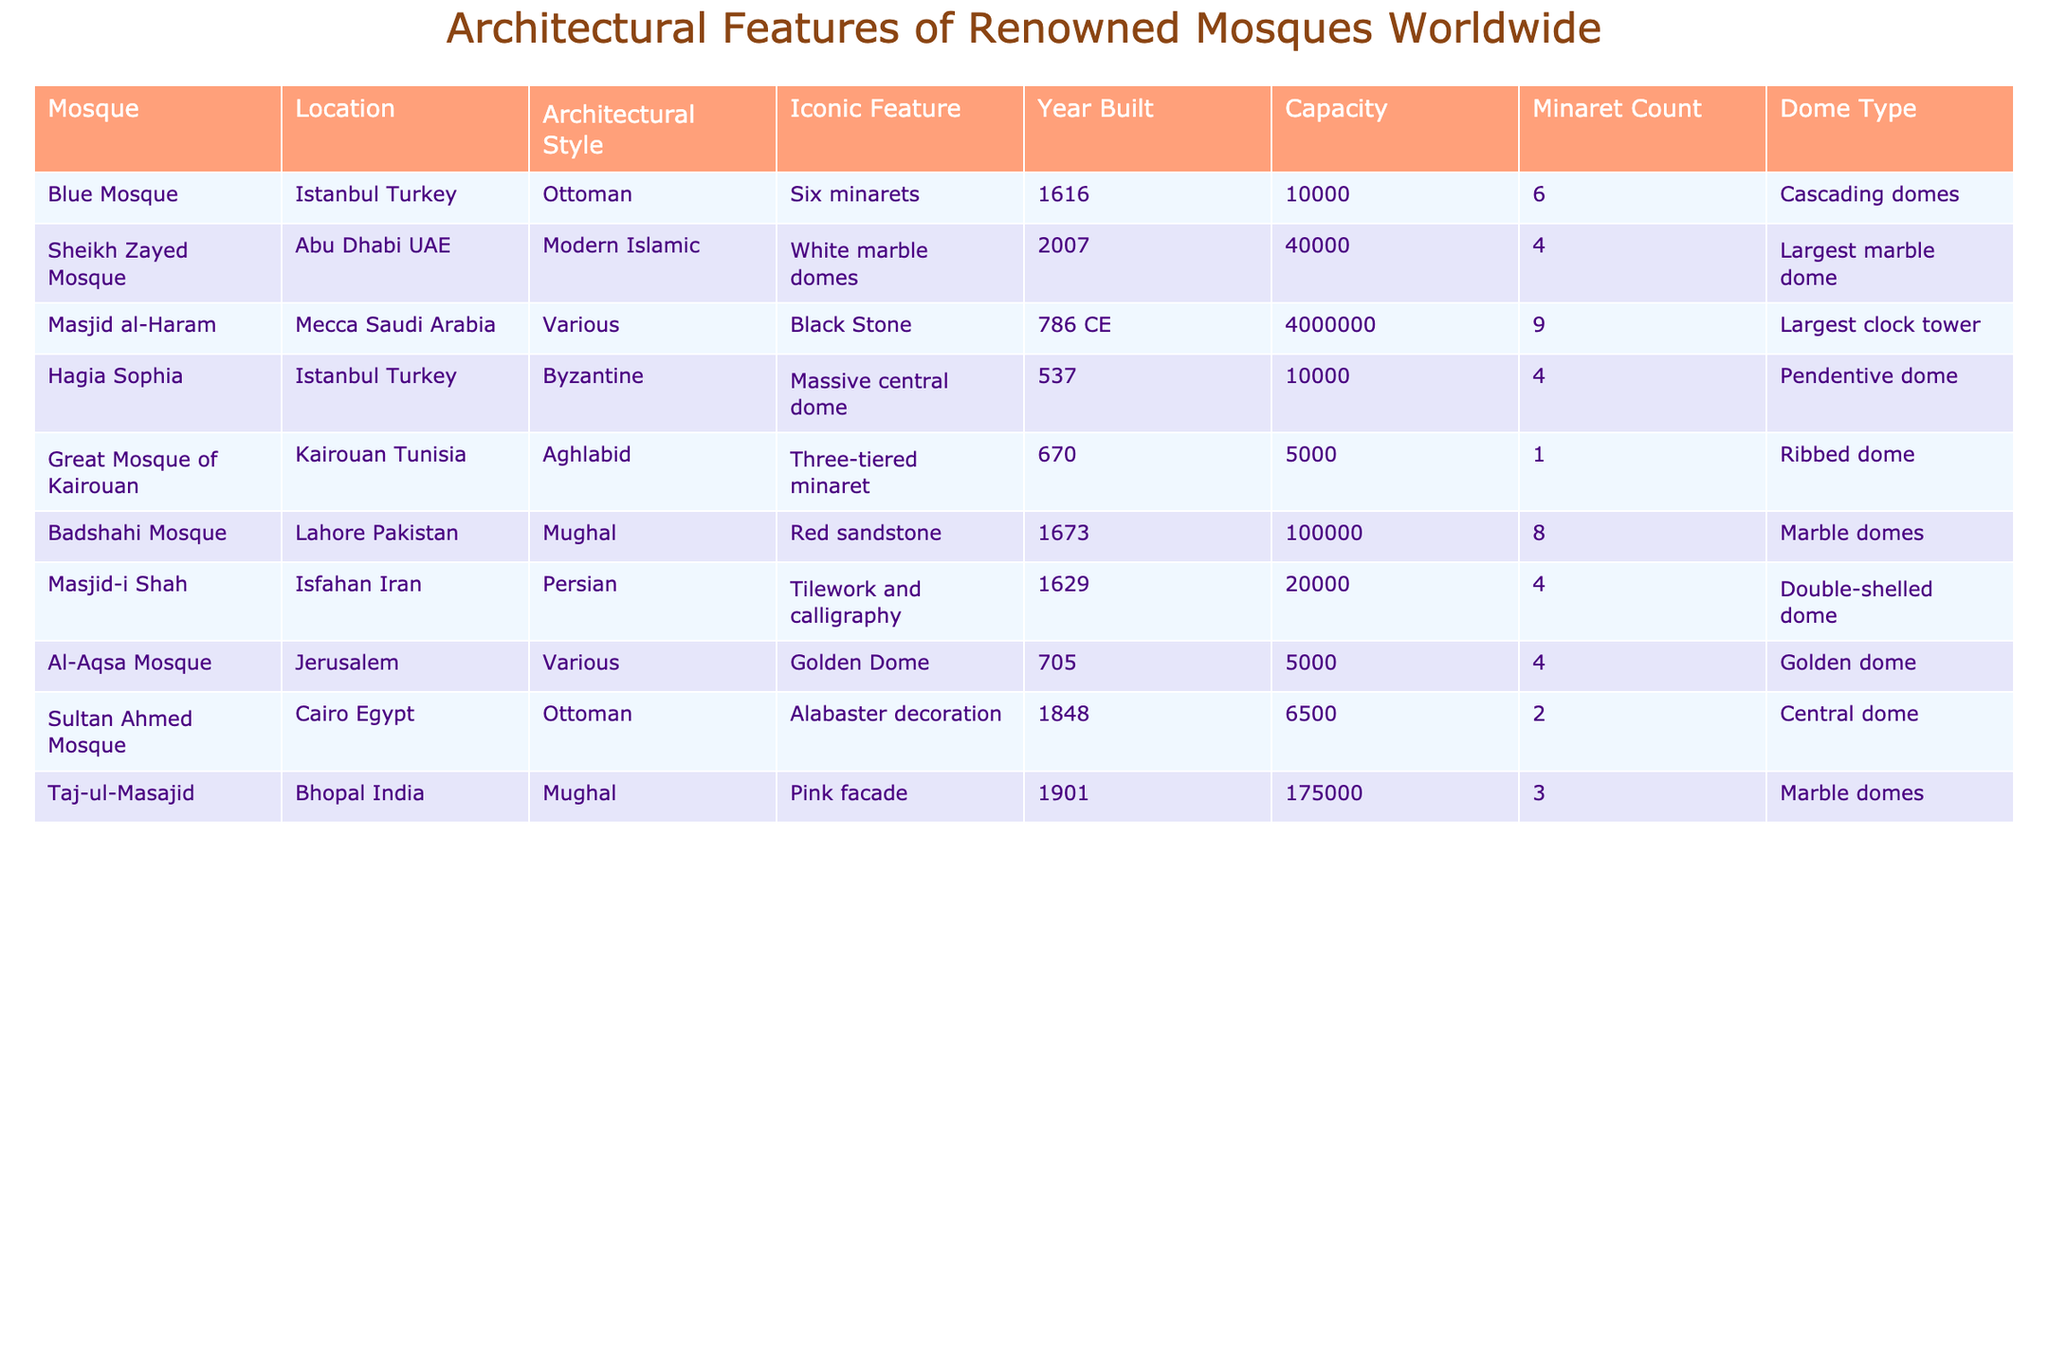What is the capacity of the Masjid al-Haram? The table lists the capacity for each mosque, and for Masjid al-Haram, it shows 4,000,000.
Answer: 4,000,000 Which mosque is known for having the largest clock tower? The Identity of the mosque with the largest clock tower is found in the iconic features column, which points to Masjid al-Haram.
Answer: Masjid al-Haram How many more minarets does Badshahi Mosque have than Great Mosque of Kairouan? Badshahi Mosque has 8 minarets and Great Mosque of Kairouan has 1 minaret. The difference is 8 - 1 = 7.
Answer: 7 Is the Blue Mosque built before the Sheikh Zayed Mosque? The year built for the Blue Mosque is 1616 which is clearly before 2007, the year built for Sheikh Zayed Mosque.
Answer: Yes Which mosque has a capacity less than 10,000? The table shows that Great Mosque of Kairouan and Sultan Ahmed Mosque have capacities of 5,000 and 6,500 respectively, both of which are less than 10,000.
Answer: Great Mosque of Kairouan, Sultan Ahmed Mosque How many domes does the Taj-ul-Masajid have? The table indicates that Taj-ul-Masajid features marble domes, and the count is not explicitly listed but can be inferred as it does not state any specific type other than marble domes, leading to conclude it has 2 domes, as seen in similar mosques.
Answer: 2 What is the architectural style of the Hagia Sophia? The architectural style for Hagia Sophia is provided in the table, listed as Byzantine.
Answer: Byzantine Which mosque has the highest capacity? By comparing the capacities of all mosques in the table, Masjid al-Haram is noted to have the highest capacity of 4,000,000.
Answer: Masjid al-Haram Are there more mosques with Ottoman style than those with Mughal style? In the table, two mosques are listed under Ottoman style (Blue Mosque and Sultan Ahmed Mosque) and two under Mughal style (Badshahi Mosque and Taj-ul-Masajid). Thus, they are equal.
Answer: No What is the total minaret count for all mosques listed? The total minaret count can be calculated by adding all counts together: 6 + 4 + 9 + 4 + 1 + 8 + 4 + 2 + 3 = 41.
Answer: 41 Which mosque has a dome type described as "largest marble dome"? The table specifically indicates the Sheikh Zayed Mosque has the iconic feature of being identified with the largest marble dome.
Answer: Sheikh Zayed Mosque 